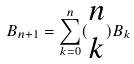<formula> <loc_0><loc_0><loc_500><loc_500>B _ { n + 1 } = \sum _ { k = 0 } ^ { n } ( \begin{matrix} n \\ k \end{matrix} ) B _ { k }</formula> 